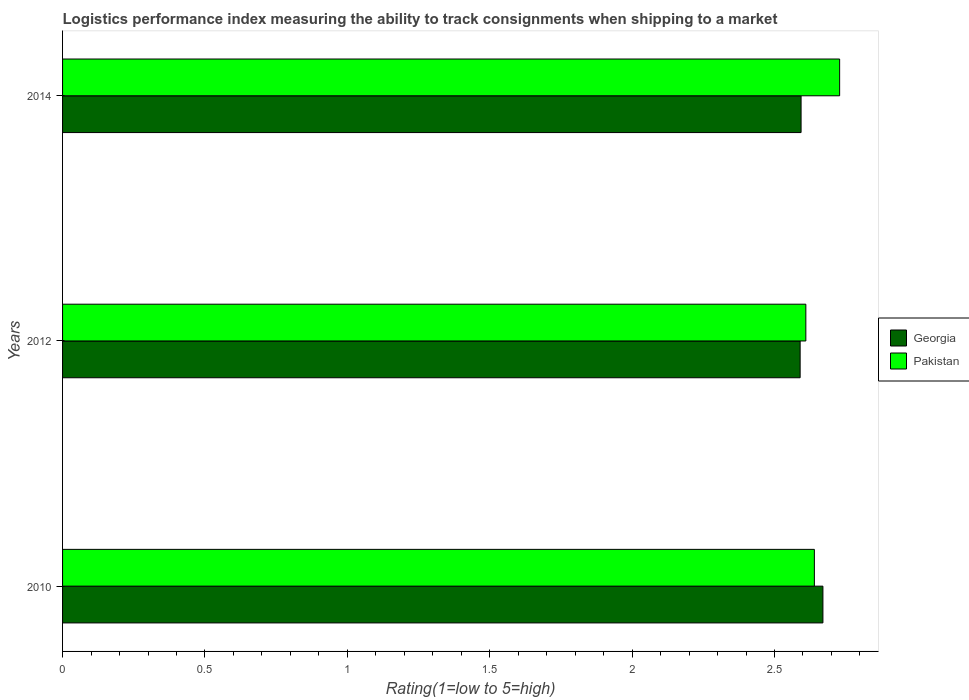How many different coloured bars are there?
Your answer should be very brief. 2. How many groups of bars are there?
Offer a terse response. 3. Are the number of bars per tick equal to the number of legend labels?
Offer a very short reply. Yes. How many bars are there on the 2nd tick from the top?
Give a very brief answer. 2. How many bars are there on the 2nd tick from the bottom?
Offer a very short reply. 2. In how many cases, is the number of bars for a given year not equal to the number of legend labels?
Your answer should be compact. 0. What is the Logistic performance index in Georgia in 2012?
Ensure brevity in your answer.  2.59. Across all years, what is the maximum Logistic performance index in Pakistan?
Ensure brevity in your answer.  2.73. Across all years, what is the minimum Logistic performance index in Pakistan?
Offer a terse response. 2.61. What is the total Logistic performance index in Georgia in the graph?
Give a very brief answer. 7.85. What is the difference between the Logistic performance index in Georgia in 2012 and that in 2014?
Provide a short and direct response. -0. What is the difference between the Logistic performance index in Pakistan in 2010 and the Logistic performance index in Georgia in 2014?
Your response must be concise. 0.05. What is the average Logistic performance index in Pakistan per year?
Make the answer very short. 2.66. In the year 2014, what is the difference between the Logistic performance index in Pakistan and Logistic performance index in Georgia?
Make the answer very short. 0.14. In how many years, is the Logistic performance index in Pakistan greater than 2.7 ?
Ensure brevity in your answer.  1. What is the ratio of the Logistic performance index in Georgia in 2012 to that in 2014?
Provide a short and direct response. 1. What is the difference between the highest and the second highest Logistic performance index in Pakistan?
Your response must be concise. 0.09. What is the difference between the highest and the lowest Logistic performance index in Pakistan?
Offer a very short reply. 0.12. In how many years, is the Logistic performance index in Pakistan greater than the average Logistic performance index in Pakistan taken over all years?
Make the answer very short. 1. Is the sum of the Logistic performance index in Georgia in 2012 and 2014 greater than the maximum Logistic performance index in Pakistan across all years?
Keep it short and to the point. Yes. What does the 1st bar from the bottom in 2014 represents?
Offer a terse response. Georgia. How many bars are there?
Provide a succinct answer. 6. How many years are there in the graph?
Ensure brevity in your answer.  3. Does the graph contain any zero values?
Your response must be concise. No. Does the graph contain grids?
Provide a succinct answer. No. Where does the legend appear in the graph?
Ensure brevity in your answer.  Center right. What is the title of the graph?
Provide a succinct answer. Logistics performance index measuring the ability to track consignments when shipping to a market. What is the label or title of the X-axis?
Offer a terse response. Rating(1=low to 5=high). What is the label or title of the Y-axis?
Your answer should be compact. Years. What is the Rating(1=low to 5=high) in Georgia in 2010?
Provide a succinct answer. 2.67. What is the Rating(1=low to 5=high) of Pakistan in 2010?
Keep it short and to the point. 2.64. What is the Rating(1=low to 5=high) of Georgia in 2012?
Offer a very short reply. 2.59. What is the Rating(1=low to 5=high) of Pakistan in 2012?
Offer a terse response. 2.61. What is the Rating(1=low to 5=high) of Georgia in 2014?
Keep it short and to the point. 2.59. What is the Rating(1=low to 5=high) in Pakistan in 2014?
Provide a succinct answer. 2.73. Across all years, what is the maximum Rating(1=low to 5=high) of Georgia?
Ensure brevity in your answer.  2.67. Across all years, what is the maximum Rating(1=low to 5=high) in Pakistan?
Give a very brief answer. 2.73. Across all years, what is the minimum Rating(1=low to 5=high) in Georgia?
Make the answer very short. 2.59. Across all years, what is the minimum Rating(1=low to 5=high) of Pakistan?
Your response must be concise. 2.61. What is the total Rating(1=low to 5=high) of Georgia in the graph?
Keep it short and to the point. 7.85. What is the total Rating(1=low to 5=high) of Pakistan in the graph?
Offer a terse response. 7.98. What is the difference between the Rating(1=low to 5=high) of Georgia in 2010 and that in 2012?
Make the answer very short. 0.08. What is the difference between the Rating(1=low to 5=high) of Georgia in 2010 and that in 2014?
Offer a very short reply. 0.08. What is the difference between the Rating(1=low to 5=high) of Pakistan in 2010 and that in 2014?
Keep it short and to the point. -0.09. What is the difference between the Rating(1=low to 5=high) of Georgia in 2012 and that in 2014?
Give a very brief answer. -0. What is the difference between the Rating(1=low to 5=high) of Pakistan in 2012 and that in 2014?
Provide a succinct answer. -0.12. What is the difference between the Rating(1=low to 5=high) of Georgia in 2010 and the Rating(1=low to 5=high) of Pakistan in 2012?
Keep it short and to the point. 0.06. What is the difference between the Rating(1=low to 5=high) of Georgia in 2010 and the Rating(1=low to 5=high) of Pakistan in 2014?
Your response must be concise. -0.06. What is the difference between the Rating(1=low to 5=high) in Georgia in 2012 and the Rating(1=low to 5=high) in Pakistan in 2014?
Your answer should be compact. -0.14. What is the average Rating(1=low to 5=high) in Georgia per year?
Keep it short and to the point. 2.62. What is the average Rating(1=low to 5=high) of Pakistan per year?
Your response must be concise. 2.66. In the year 2012, what is the difference between the Rating(1=low to 5=high) of Georgia and Rating(1=low to 5=high) of Pakistan?
Your response must be concise. -0.02. In the year 2014, what is the difference between the Rating(1=low to 5=high) of Georgia and Rating(1=low to 5=high) of Pakistan?
Offer a very short reply. -0.14. What is the ratio of the Rating(1=low to 5=high) of Georgia in 2010 to that in 2012?
Make the answer very short. 1.03. What is the ratio of the Rating(1=low to 5=high) of Pakistan in 2010 to that in 2012?
Your answer should be very brief. 1.01. What is the ratio of the Rating(1=low to 5=high) of Georgia in 2010 to that in 2014?
Keep it short and to the point. 1.03. What is the ratio of the Rating(1=low to 5=high) in Pakistan in 2010 to that in 2014?
Give a very brief answer. 0.97. What is the ratio of the Rating(1=low to 5=high) in Georgia in 2012 to that in 2014?
Give a very brief answer. 1. What is the ratio of the Rating(1=low to 5=high) of Pakistan in 2012 to that in 2014?
Give a very brief answer. 0.96. What is the difference between the highest and the second highest Rating(1=low to 5=high) in Georgia?
Provide a succinct answer. 0.08. What is the difference between the highest and the second highest Rating(1=low to 5=high) in Pakistan?
Your answer should be very brief. 0.09. What is the difference between the highest and the lowest Rating(1=low to 5=high) of Georgia?
Provide a succinct answer. 0.08. What is the difference between the highest and the lowest Rating(1=low to 5=high) of Pakistan?
Give a very brief answer. 0.12. 